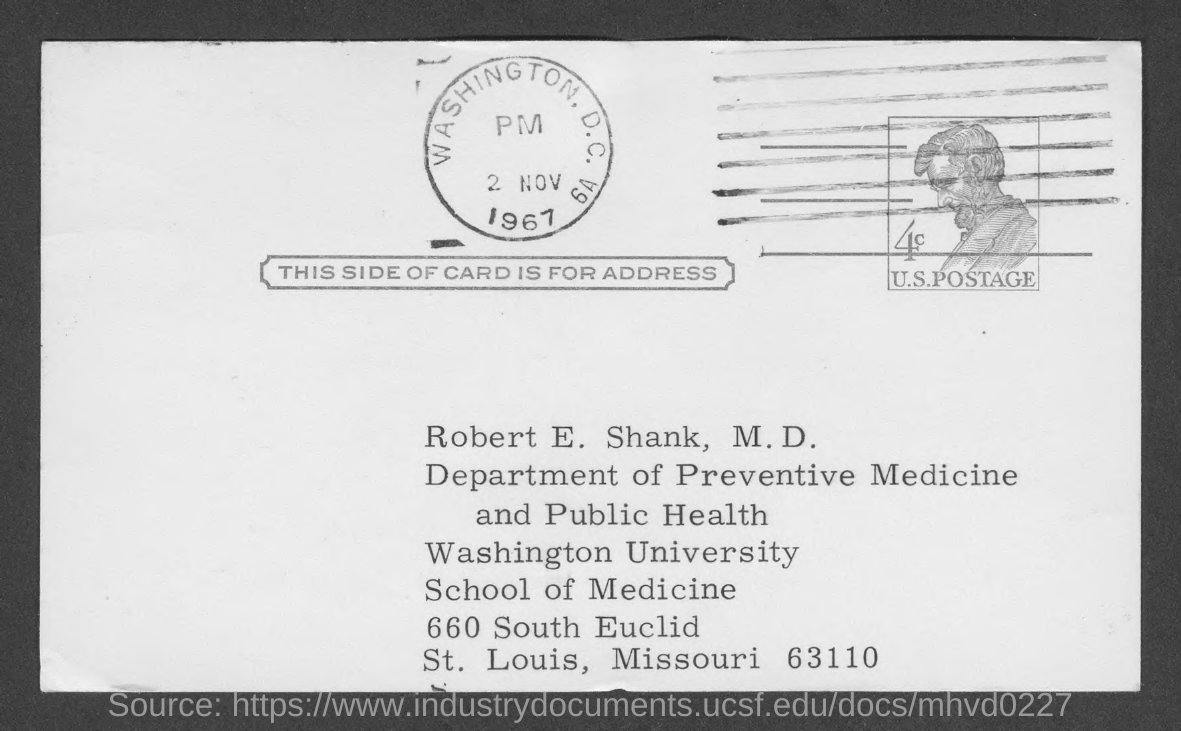Mention a couple of crucial points in this snapshot. The date mentioned in the given page is November 2, 1967. The name of the university mentioned in the given form is Washington University. The name mentioned in the given card is Robert E. Shank. The given card mentions a department named "Department of Preventive Medicine and Public Health. This side of the card displays the address. 